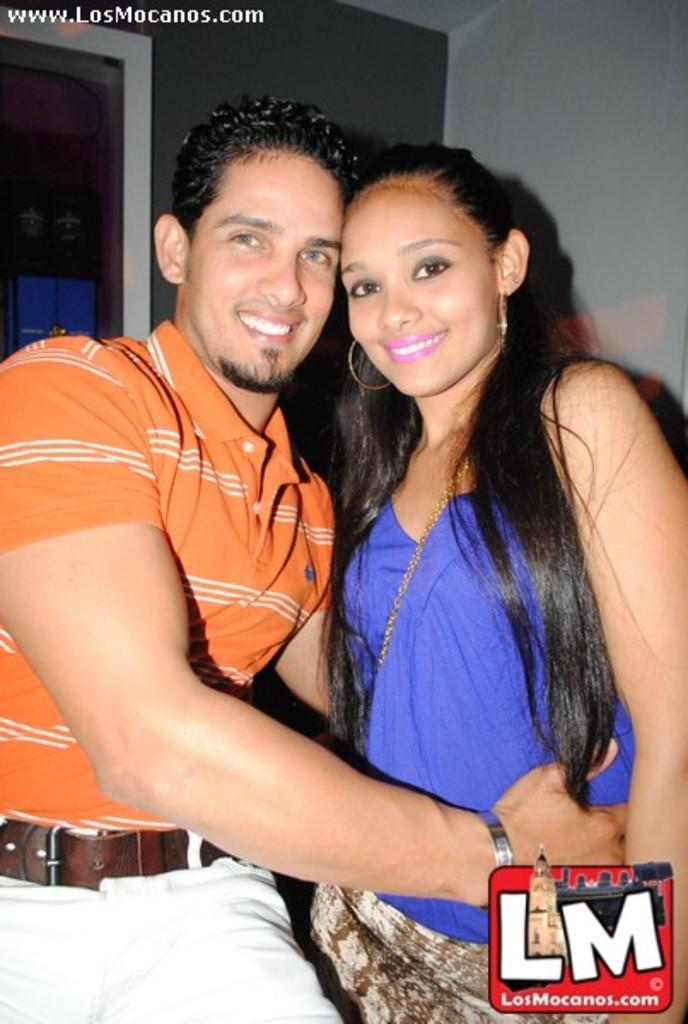How many people are in the image? There are two persons in the image. What are the two persons doing in the image? The two persons are standing and smiling. What can be seen in the background of the image? There is a wall in the background of the image. What type of receipt can be seen in the hands of one of the persons in the image? There is no receipt present in the image; both persons are standing and smiling with empty hands. 